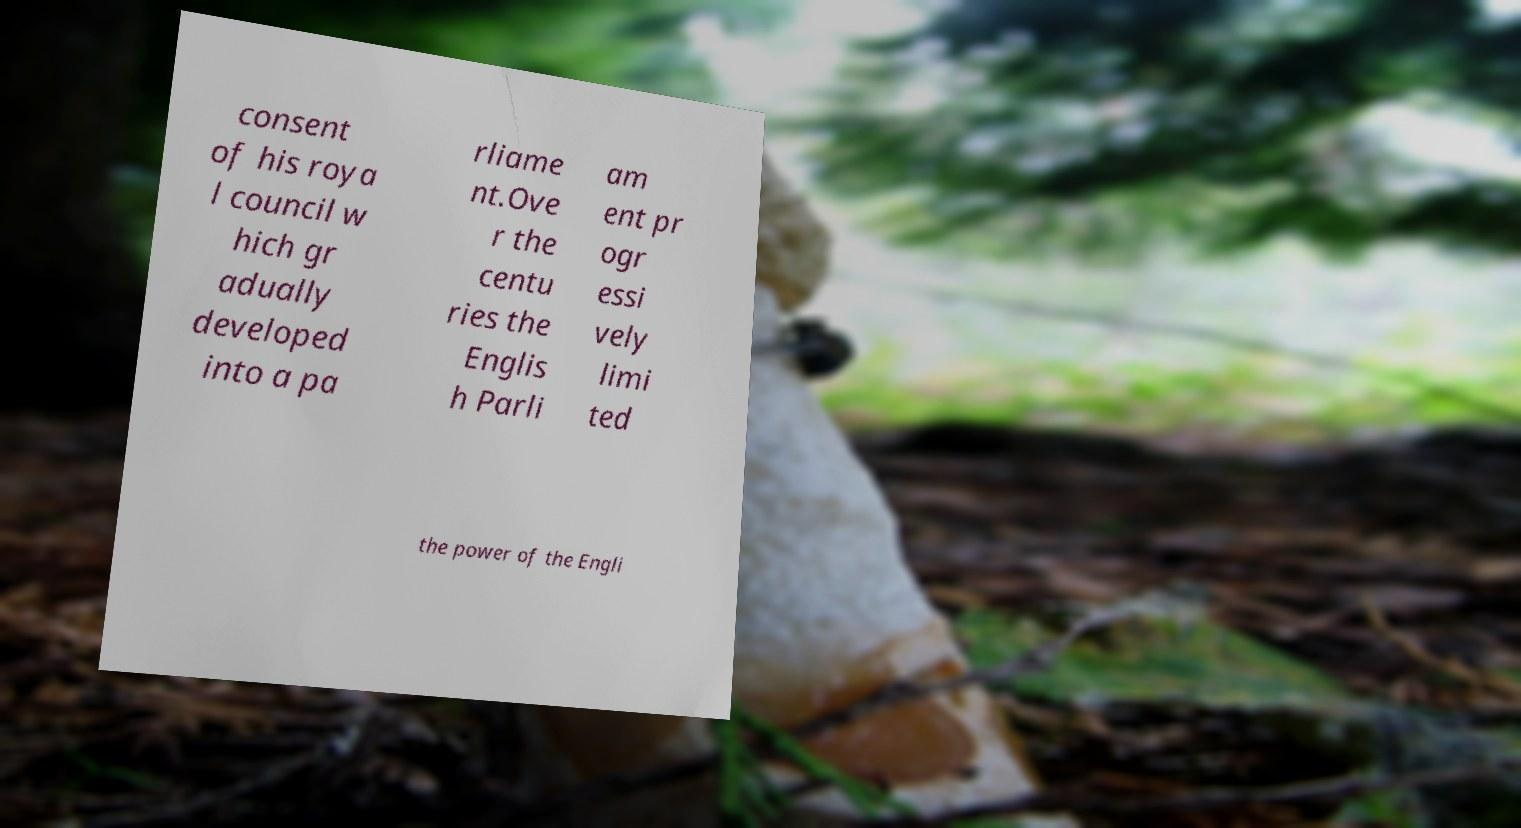Could you assist in decoding the text presented in this image and type it out clearly? consent of his roya l council w hich gr adually developed into a pa rliame nt.Ove r the centu ries the Englis h Parli am ent pr ogr essi vely limi ted the power of the Engli 